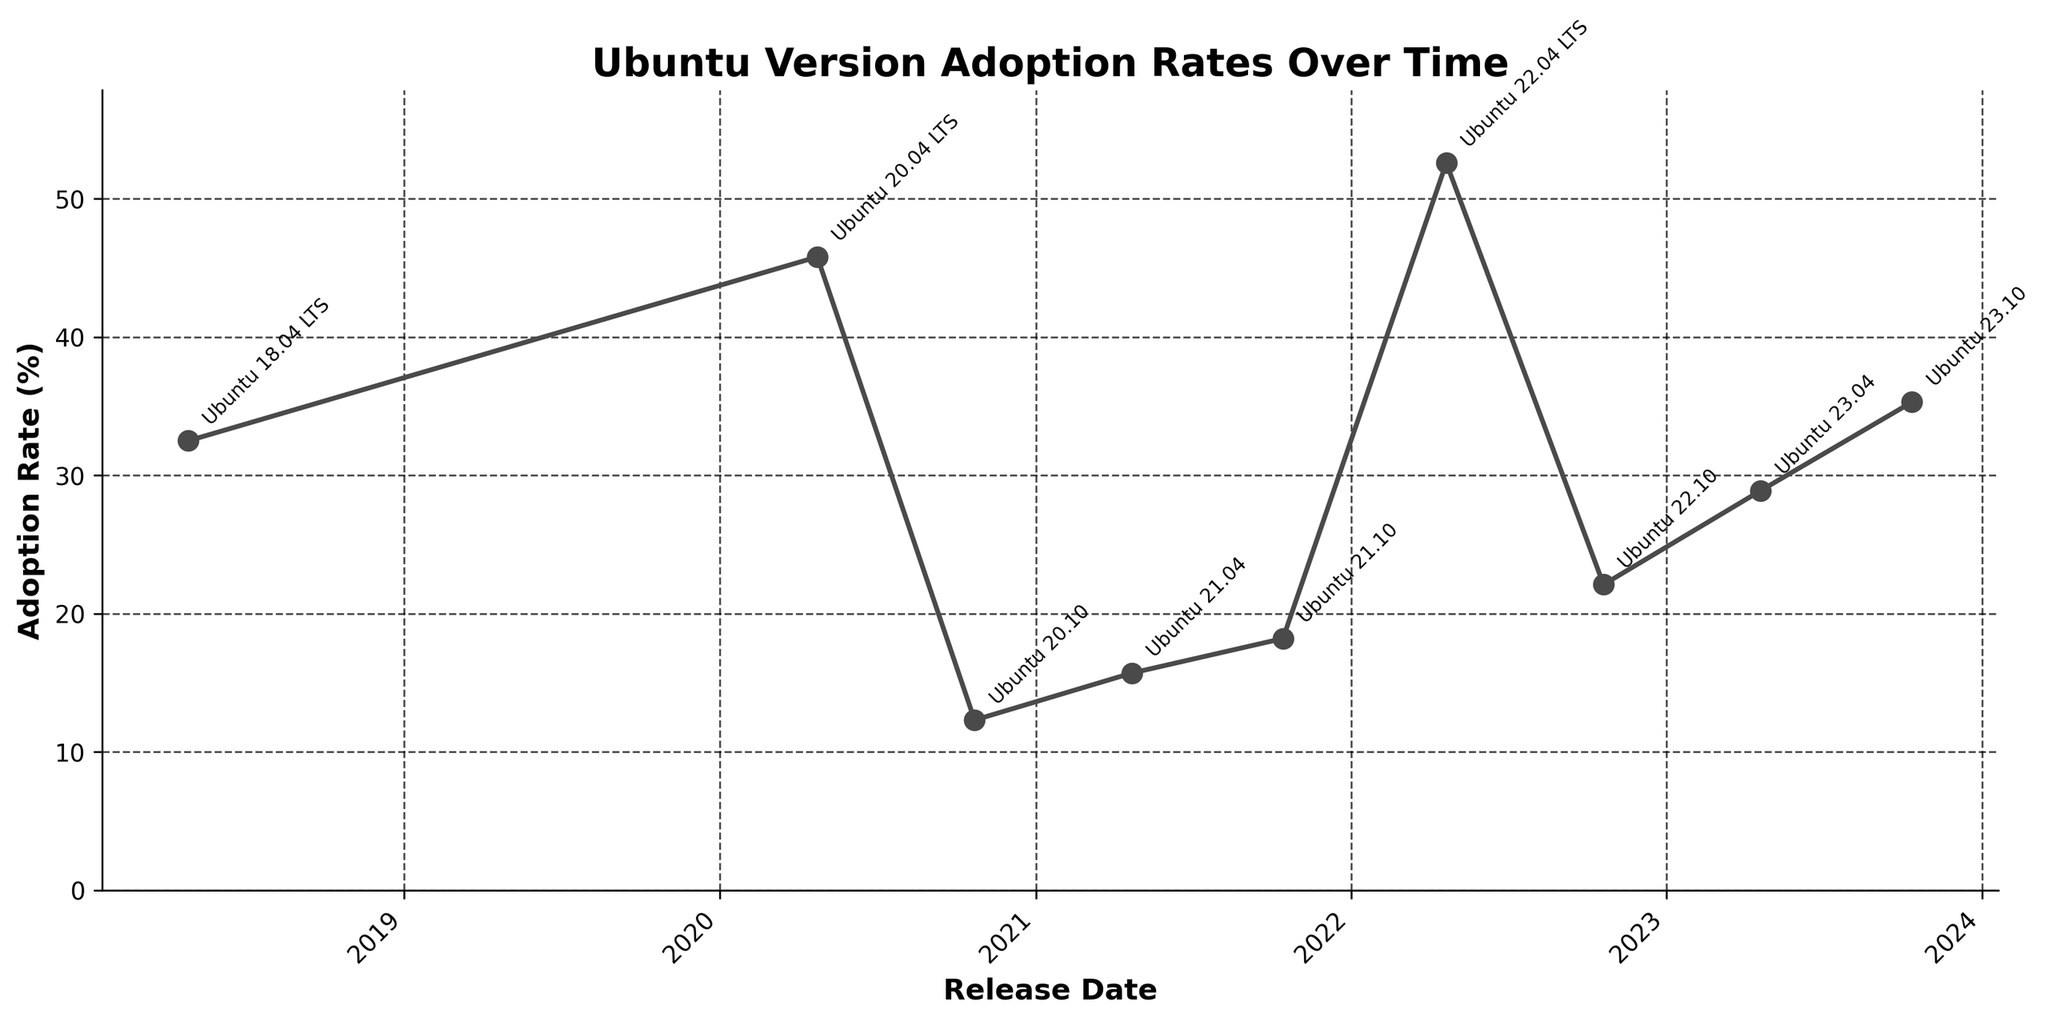Which Ubuntu version has the highest adoption rate? The Ubuntu version with the highest adoption rate can be identified by looking at the peak point on the graph. The highest point on the line chart corresponds to an adoption rate of 52.6%, which is for Ubuntu 22.04 LTS.
Answer: Ubuntu 22.04 LTS Which Ubuntu version has the lowest adoption rate? The lowest adoption rate can be determined by finding the lowest point on the chart. The smallest adoption rate is 12.3%, corresponding to Ubuntu 20.10.
Answer: Ubuntu 20.10 What is the difference in adoption rates between Ubuntu 20.04 LTS and Ubuntu 22.04 LTS? Find the adoption rates for both versions and subtract the rate for Ubuntu 20.04 LTS (45.8%) from the rate for Ubuntu 22.04 LTS (52.6%). This results in a difference of 6.8%.
Answer: 6.8% How does the adoption rate of Ubuntu 23.04 compare to Ubuntu 23.10? To compare the adoption rates, look at the points corresponding to both versions on the line chart. Ubuntu 23.10 has an adoption rate of 35.3%, which is higher than the rate for Ubuntu 23.04 at 28.9%.
Answer: Ubuntu 23.10 is higher What is the average adoption rate among all the Ubuntu versions listed? Sum all the adoption rates and divide by the number of versions. The sum of the adoption rates is 32.5 + 45.8 + 12.3 + 15.7 + 18.2 + 52.6 + 22.1 + 28.9 + 35.3 = 263.4. There are 9 versions listed, so the average is 263.4/9 = 29.27%.
Answer: 29.27% Which Ubuntu version experienced the largest increase in adoption rate compared to its predecessor? To find this, calculate the differences between consecutive adoption rates and identify the largest difference. The largest increase is from Ubuntu 21.10 (18.2%) to Ubuntu 22.04 LTS (52.6%), an increase of 34.4%.
Answer: Ubuntu 22.04 LTS What trend can be observed from the adoption rates of LTS versions compared to non-LTS versions? By examining the adoption rates for LTS versions (Ubuntu 18.04, 20.04, and 22.04) against non-LTS versions, it can be seen that LTS versions have significantly higher adoption rates compared to non-LTS versions, indicating a preference for LTS releases among users.
Answer: LTS versions are more adopted What is the time gap between the releases of Ubuntu 20.04 LTS and Ubuntu 22.04 LTS? Locate the release dates for both versions: Ubuntu 20.04 LTS (2020-04-23) and Ubuntu 22.04 LTS (2022-04-21). Calculate the difference in time, which is approximately 2 years.
Answer: 2 years Which period saw the most significant fluctuation in adoption rates? The period between Ubuntu 21.10 (18.2%) and Ubuntu 22.04 LTS (52.6%) saw the most significant fluctuation, with a dramatic increase of 34.4%.
Answer: Between Ubuntu 21.10 and 22.04 LTS How does the adoption rate change from the earliest to the latest version listed? Identify the adoption rate for the earliest version (Ubuntu 18.04 LTS, 32.5%) and the latest version (Ubuntu 23.10, 35.3%). The change in adoption rate is 35.3% - 32.5% = 2.8%.
Answer: Increased by 2.8% 